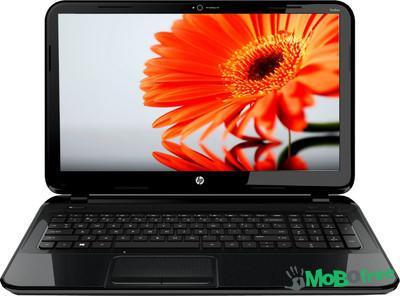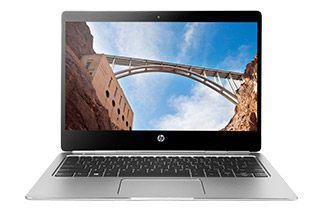The first image is the image on the left, the second image is the image on the right. Considering the images on both sides, is "The laptop in the right image is displayed turned at an angle." valid? Answer yes or no. No. 